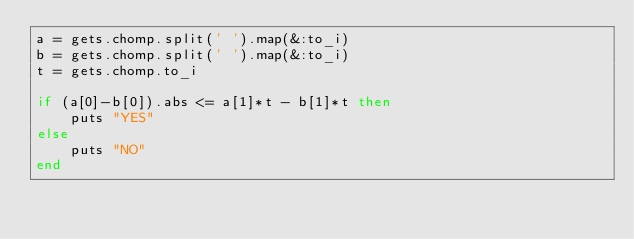<code> <loc_0><loc_0><loc_500><loc_500><_Ruby_>a = gets.chomp.split(' ').map(&:to_i)
b = gets.chomp.split(' ').map(&:to_i)
t = gets.chomp.to_i

if (a[0]-b[0]).abs <= a[1]*t - b[1]*t then
    puts "YES"
else
    puts "NO"
end</code> 